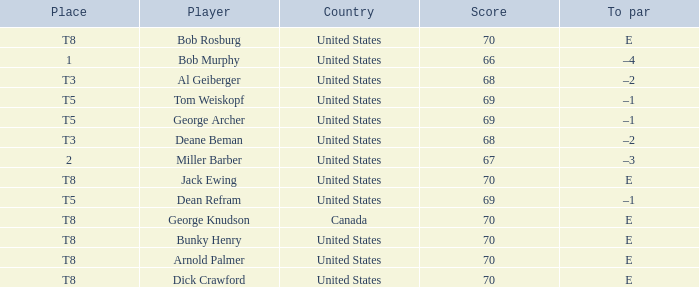When Bunky Henry placed t8, what was his To par? E. 